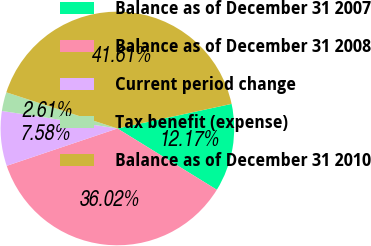<chart> <loc_0><loc_0><loc_500><loc_500><pie_chart><fcel>Balance as of December 31 2007<fcel>Balance as of December 31 2008<fcel>Current period change<fcel>Tax benefit (expense)<fcel>Balance as of December 31 2010<nl><fcel>12.17%<fcel>36.02%<fcel>7.58%<fcel>2.61%<fcel>41.61%<nl></chart> 